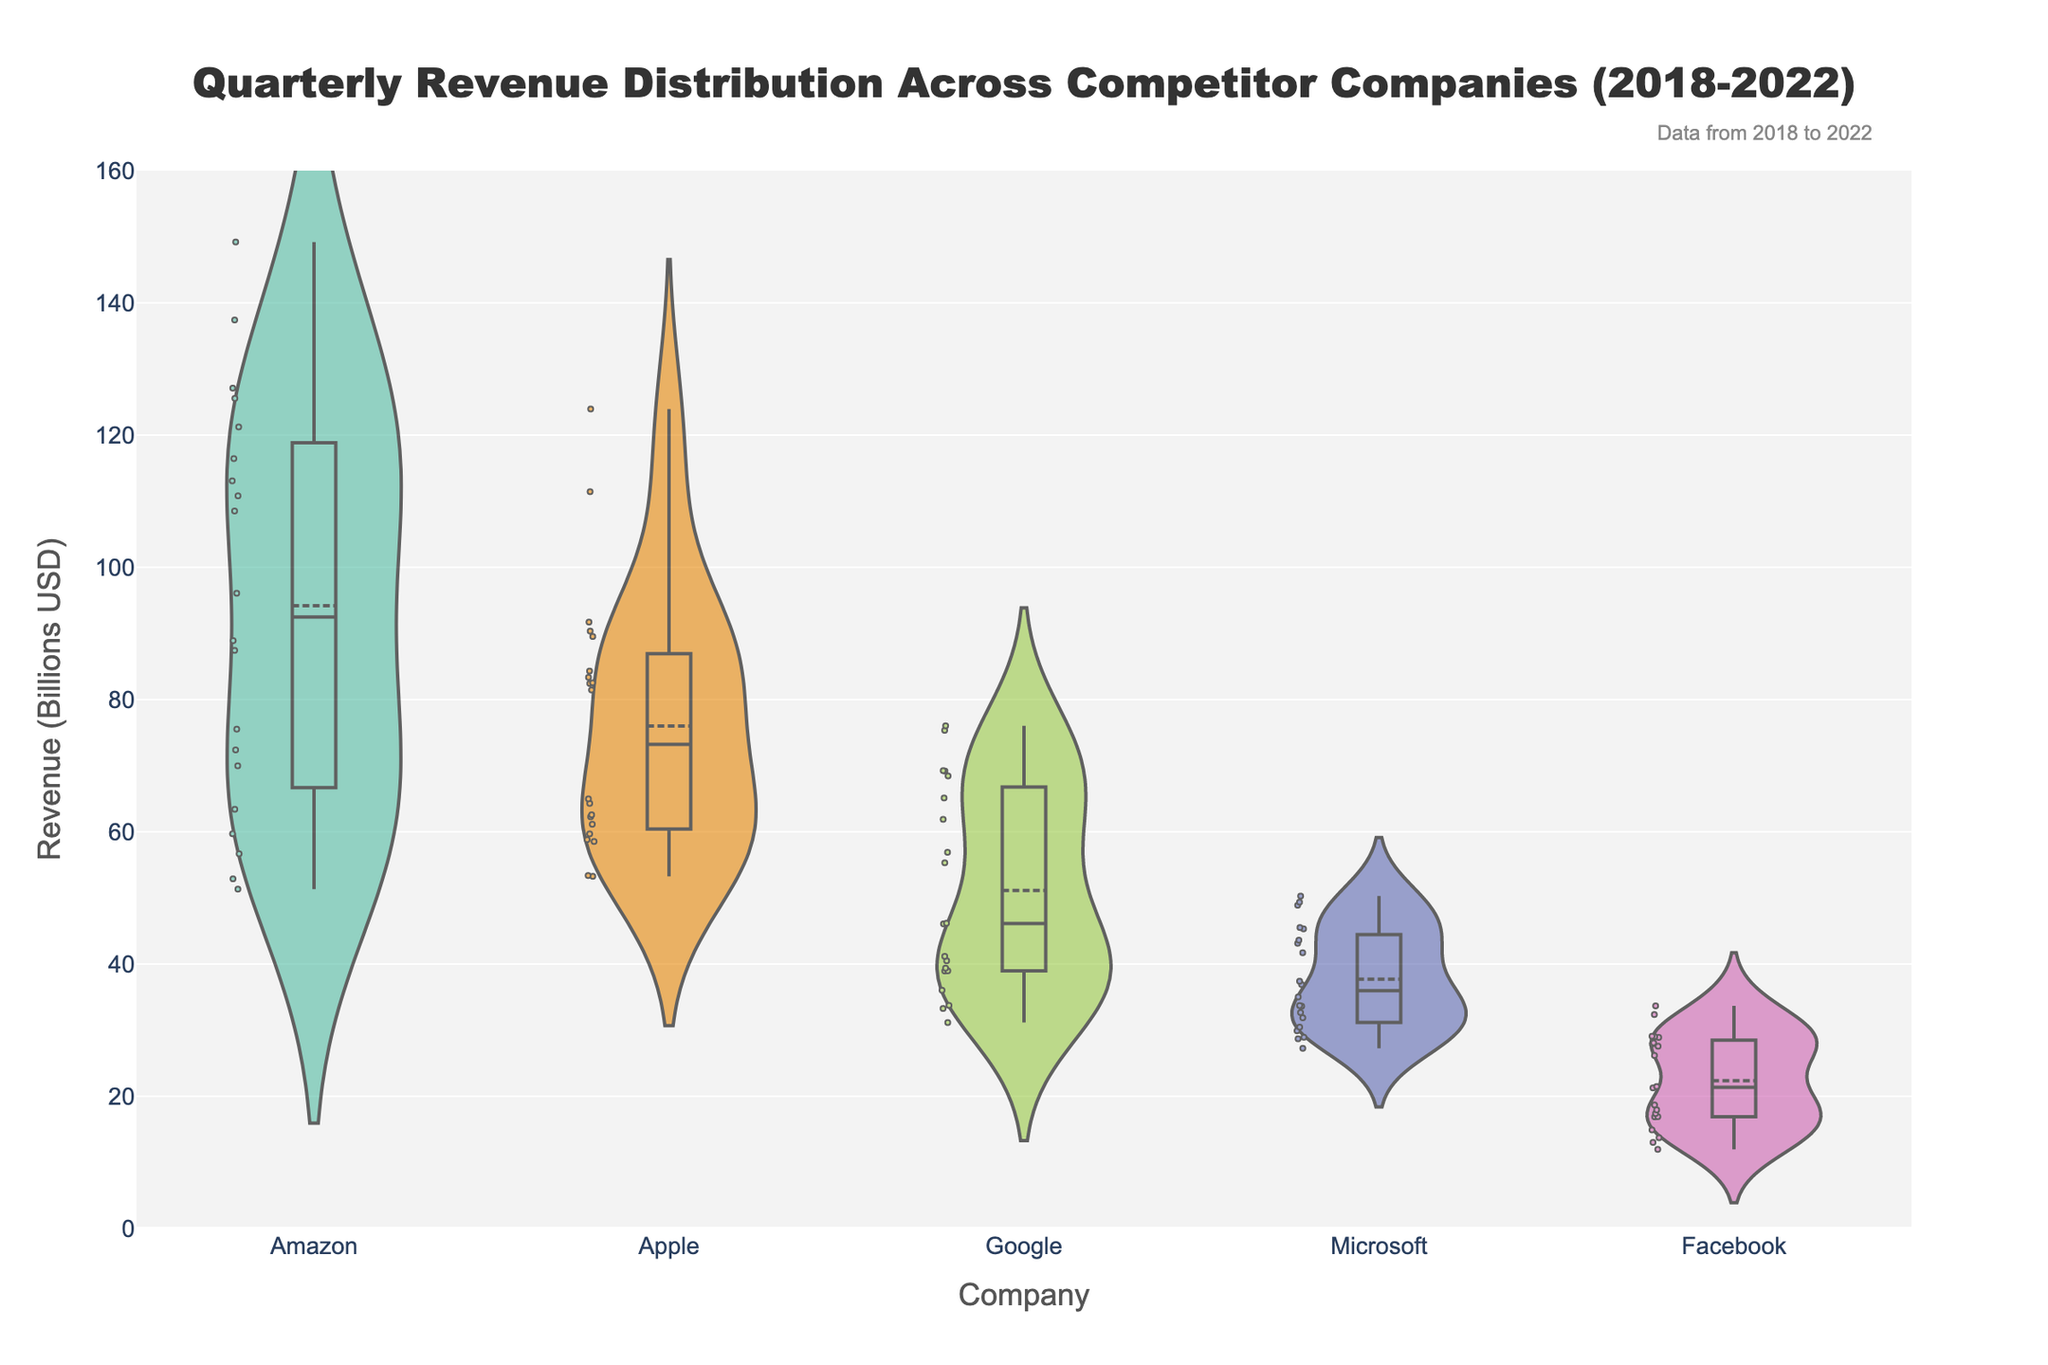what is the title of the figure? The title is usually positioned at the top of the figure in a larger font size. From the description, we can see the title text provided in the code.
Answer: Quarterly Revenue Distribution Across Competitor Companies (2018-2022) how many companies are represented in the figure? By counting the unique labels on the x-axis, which represent different companies, we can determine the total number of companies.
Answer: 5 which company shows the widest spread in revenue distribution? By observing the width of the violin plots, which indicate the spread of the data, we can see that the company with the widest spread has the most variation in revenue.
Answer: Amazon what is the median quarterly revenue for Facebook? The median is represented by the white line within the violin plot's box. We can locate this line and read off the corresponding value from the y-axis.
Answer: ~25 billion USD which company has the highest peak revenue, and what is that value? The highest peak in the violin plot shows the company's maximum revenue. We can identify this by finding the tallest point in the plots and reading off the corresponding value.
Answer: Amazon, ~150 billion USD compare the median quarterly revenues of Apple and Microsoft. Which company has a higher median value? By looking at the median lines (white lines) in the violin plots for both Apple and Microsoft and comparing their positions on the y-axis, we can determine which is higher.
Answer: Apple what is the range of quarterly revenues for Google? The range can be determined by finding the minimum and maximum values in Google's violin plot and subtracting the minimum from the maximum revenue value.
Answer: ~45.0 billion USD (76.0 - 31.0 billion USD) during what year did Amazon have a substantial increase in its quarterly revenue distribution compared to previous years? By looking at the concentration of points in the violin plot for Amazon over the years, a substantial increase would show up as an upward shift beginning from a particular year.
Answer: 2020 how do the distributions of revenues for Q1 compare among the companies? To compare the distributions for Q1, observe the points and densities corresponding to Q1 for each company. Look for trends or notable differences.
Answer: Amazon and Apple show higher density and spread in Q1, indicating larger and more variable revenues compared to other companies what is the interquartile range (IQR) for Microsoft's quarterly revenue? The IQR can be found by identifying the first and third quartiles (the edges of the box in the violin plot) and calculating the difference between these two values for Microsoft.
Answer: ~13.5 billion USD 